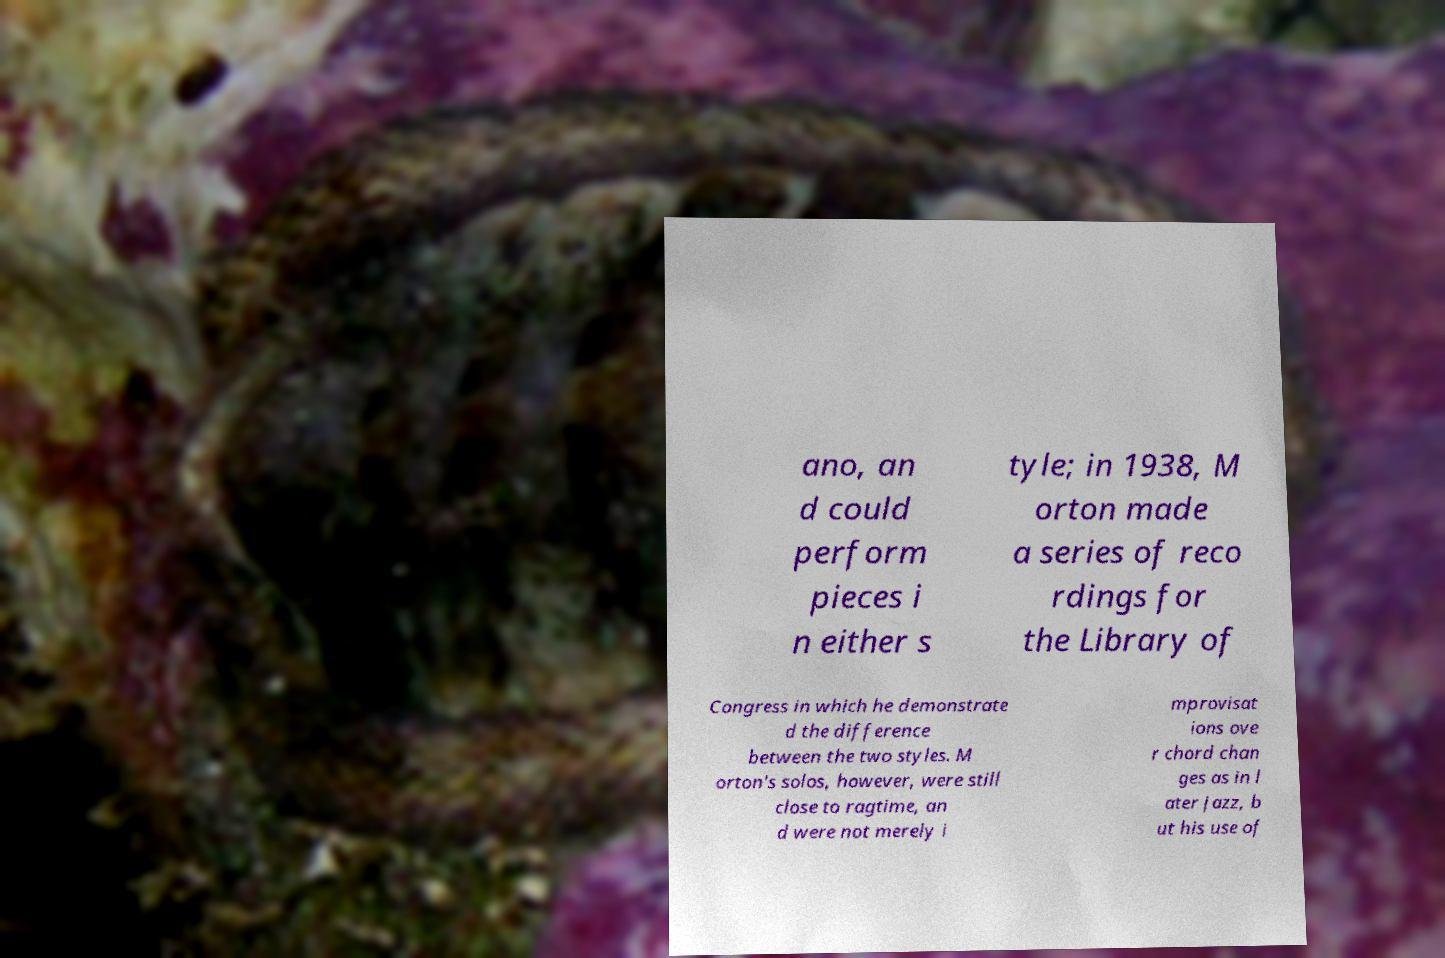Can you accurately transcribe the text from the provided image for me? ano, an d could perform pieces i n either s tyle; in 1938, M orton made a series of reco rdings for the Library of Congress in which he demonstrate d the difference between the two styles. M orton's solos, however, were still close to ragtime, an d were not merely i mprovisat ions ove r chord chan ges as in l ater jazz, b ut his use of 